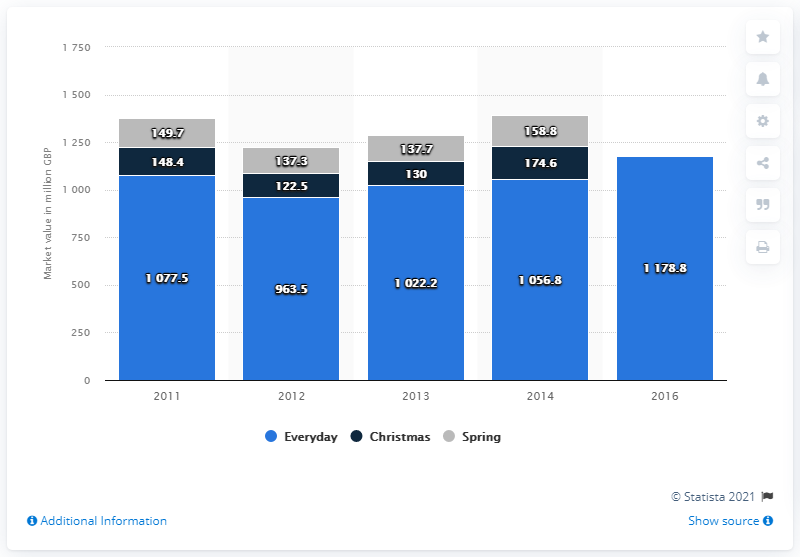Indicate a few pertinent items in this graphic. What is the average value for spring temperatures in the period of 2011-2013? Specifically, the average spring temperature was 141.567... The blue bar in the chart represents the daily data for a particular variable. 